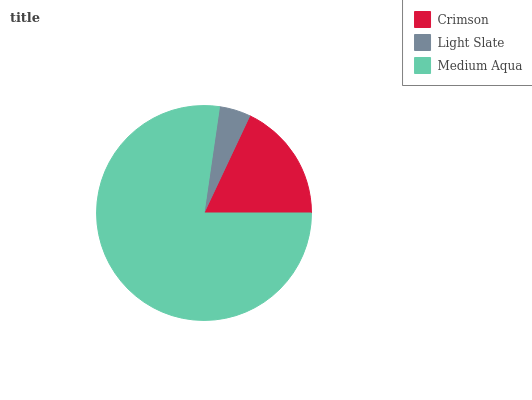Is Light Slate the minimum?
Answer yes or no. Yes. Is Medium Aqua the maximum?
Answer yes or no. Yes. Is Medium Aqua the minimum?
Answer yes or no. No. Is Light Slate the maximum?
Answer yes or no. No. Is Medium Aqua greater than Light Slate?
Answer yes or no. Yes. Is Light Slate less than Medium Aqua?
Answer yes or no. Yes. Is Light Slate greater than Medium Aqua?
Answer yes or no. No. Is Medium Aqua less than Light Slate?
Answer yes or no. No. Is Crimson the high median?
Answer yes or no. Yes. Is Crimson the low median?
Answer yes or no. Yes. Is Light Slate the high median?
Answer yes or no. No. Is Medium Aqua the low median?
Answer yes or no. No. 